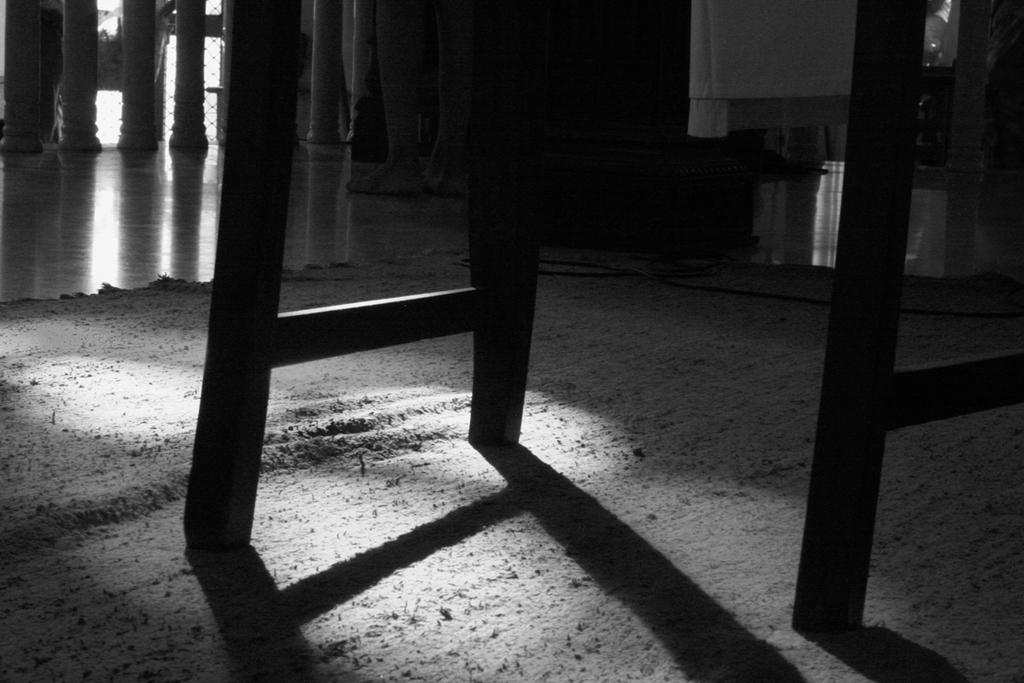What is the color scheme of the picture? The picture is black and white. How would you describe the background of the image? The background of the picture is dark. What can be seen in the picture besides the background? There are objects visible in the picture. What type of floor is present in the image? There is a floor in the picture, and it has a floor carpet. Where is the shelf with the crown displayed in the image? There is no shelf or crown present in the image. What type of property is shown in the image? The image does not depict any property; it is a black and white picture with a dark background and visible objects. 